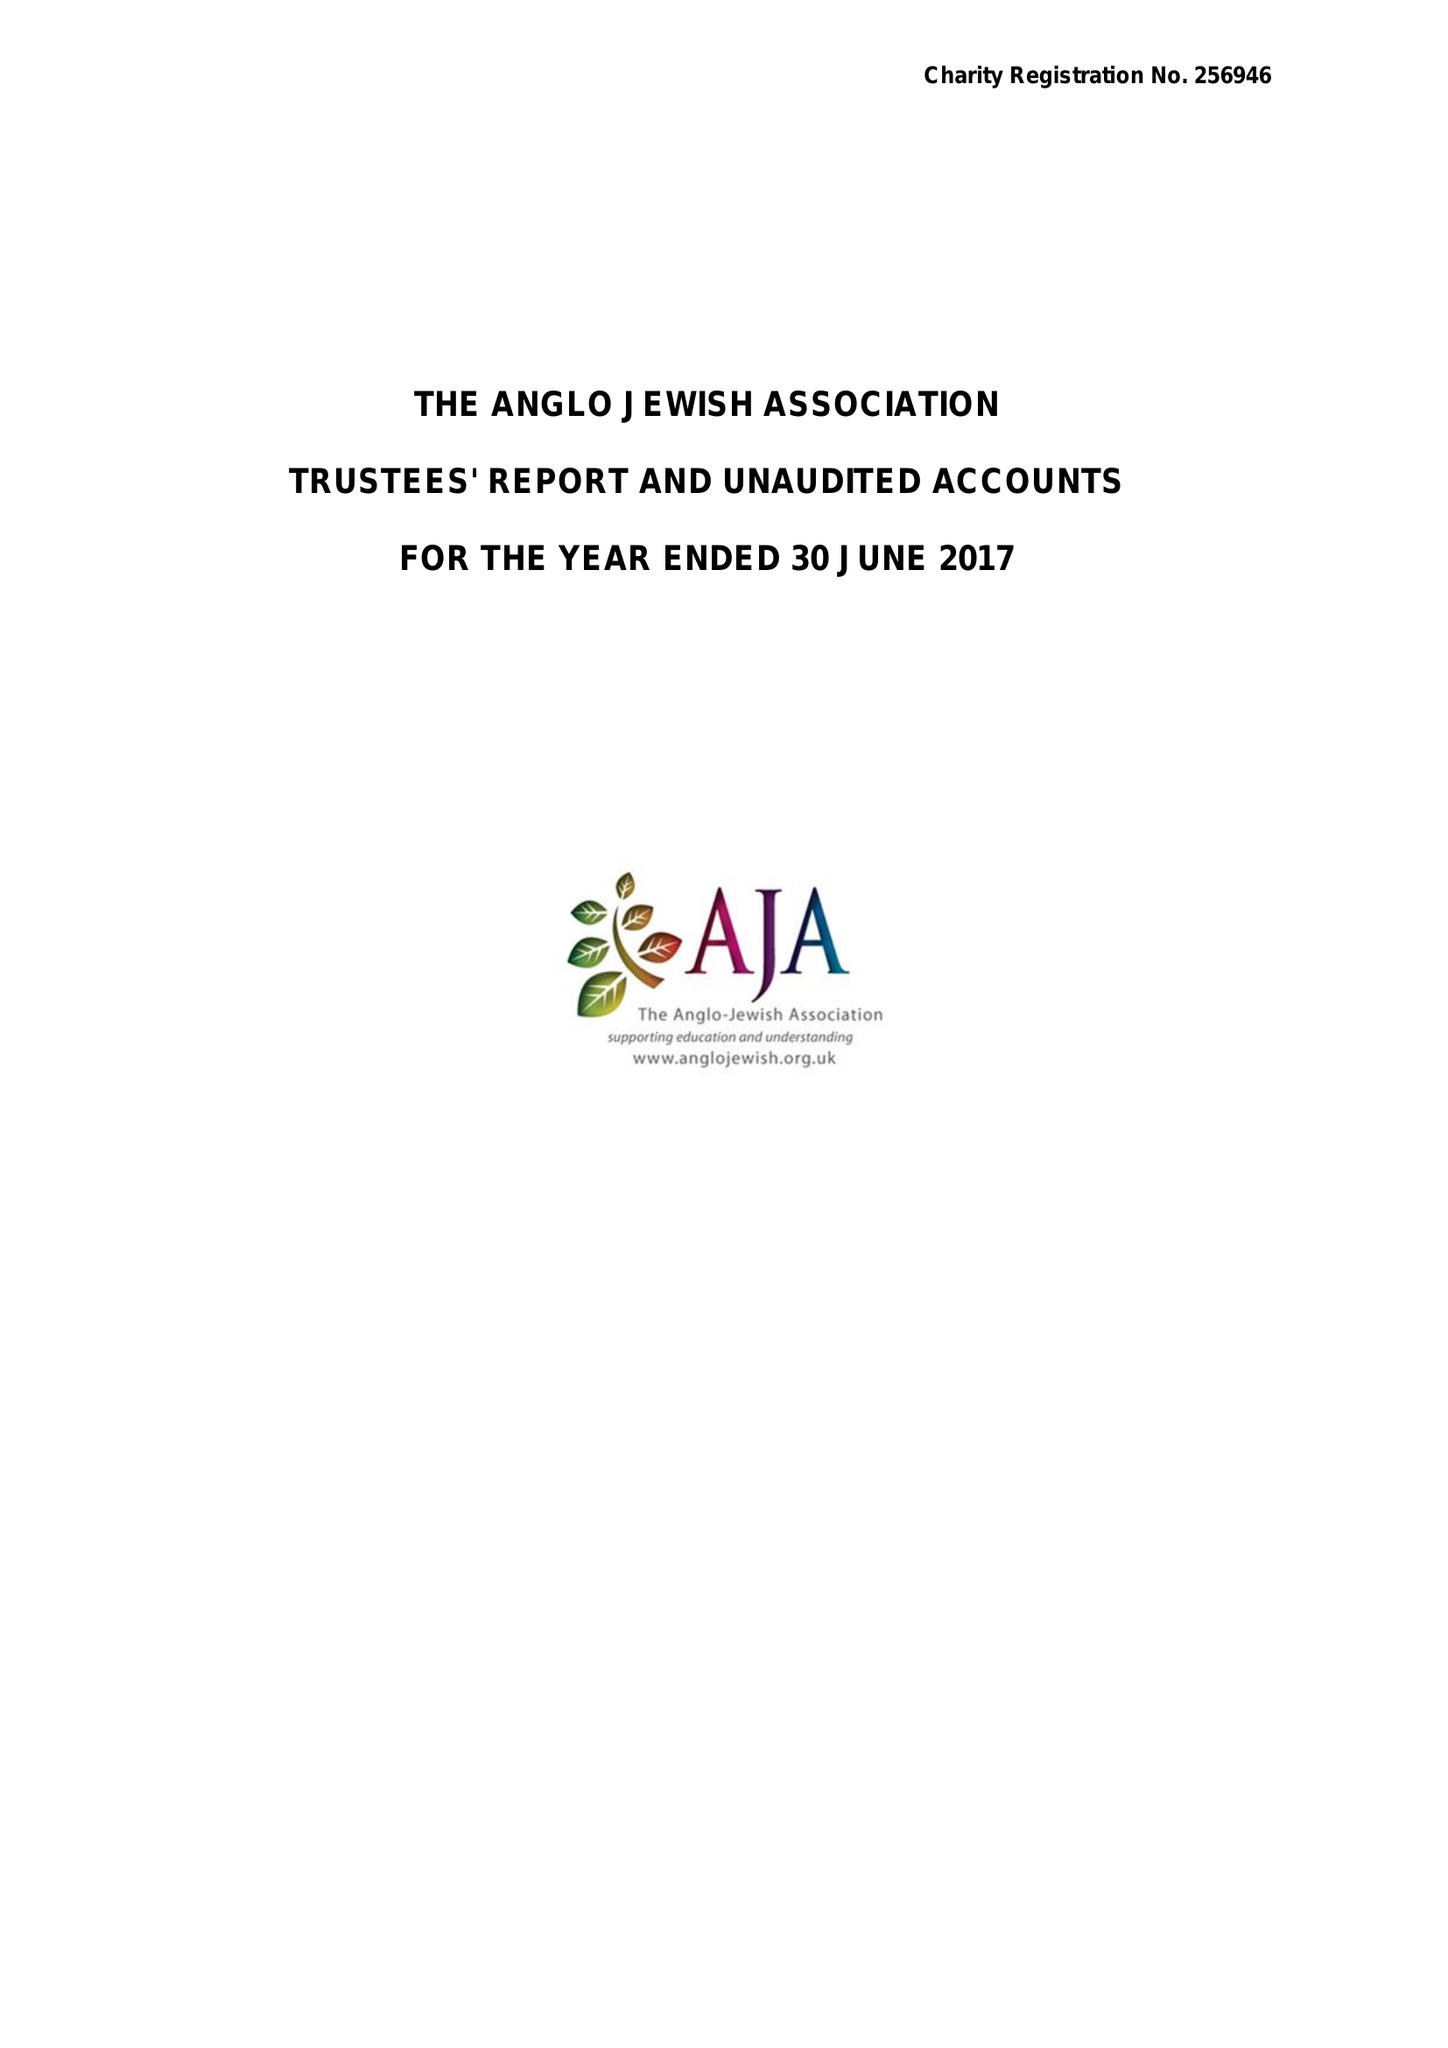What is the value for the spending_annually_in_british_pounds?
Answer the question using a single word or phrase. 95177.00 